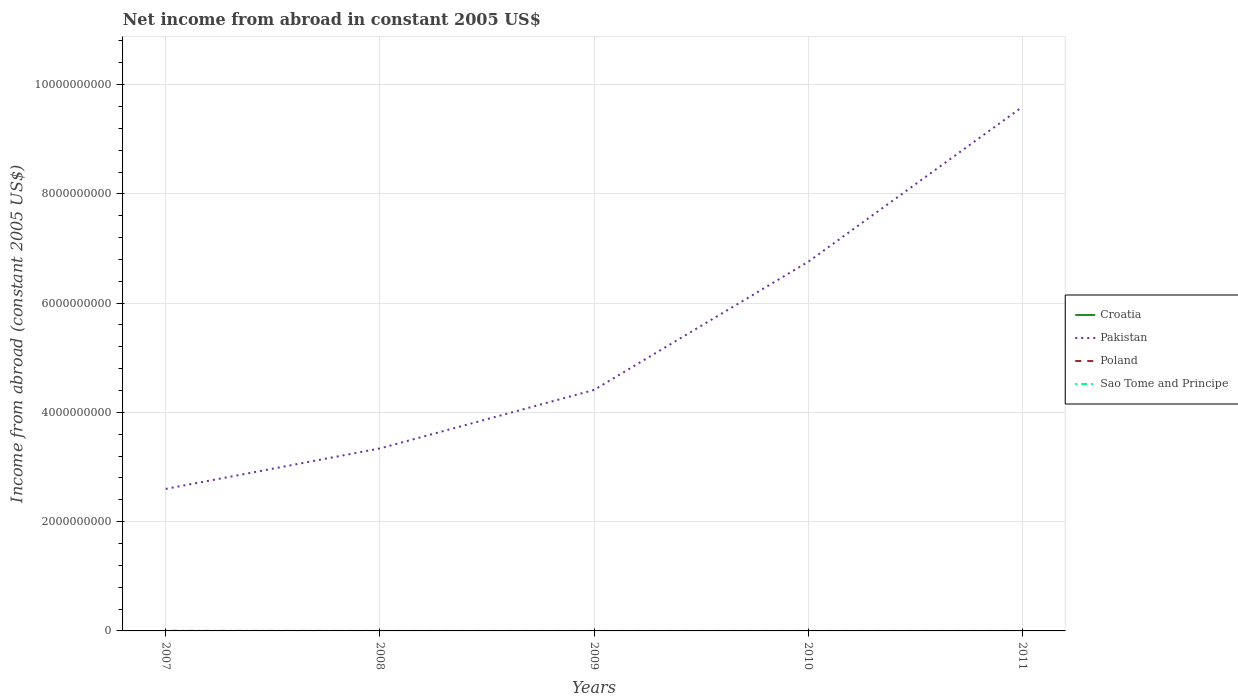How many different coloured lines are there?
Your answer should be very brief. 2. Does the line corresponding to Croatia intersect with the line corresponding to Pakistan?
Offer a very short reply. No. Is the number of lines equal to the number of legend labels?
Provide a short and direct response. No. Across all years, what is the maximum net income from abroad in Pakistan?
Your response must be concise. 2.60e+09. What is the total net income from abroad in Pakistan in the graph?
Offer a terse response. -4.16e+09. What is the difference between the highest and the second highest net income from abroad in Sao Tome and Principe?
Your response must be concise. 4.47e+06. How many lines are there?
Provide a succinct answer. 2. Are the values on the major ticks of Y-axis written in scientific E-notation?
Offer a terse response. No. Does the graph contain any zero values?
Offer a very short reply. Yes. Does the graph contain grids?
Ensure brevity in your answer.  Yes. Where does the legend appear in the graph?
Offer a very short reply. Center right. How many legend labels are there?
Provide a succinct answer. 4. What is the title of the graph?
Keep it short and to the point. Net income from abroad in constant 2005 US$. What is the label or title of the X-axis?
Your answer should be very brief. Years. What is the label or title of the Y-axis?
Your answer should be very brief. Income from abroad (constant 2005 US$). What is the Income from abroad (constant 2005 US$) in Pakistan in 2007?
Make the answer very short. 2.60e+09. What is the Income from abroad (constant 2005 US$) of Poland in 2007?
Provide a short and direct response. 0. What is the Income from abroad (constant 2005 US$) of Sao Tome and Principe in 2007?
Keep it short and to the point. 4.47e+06. What is the Income from abroad (constant 2005 US$) in Croatia in 2008?
Offer a very short reply. 0. What is the Income from abroad (constant 2005 US$) in Pakistan in 2008?
Your response must be concise. 3.34e+09. What is the Income from abroad (constant 2005 US$) in Poland in 2008?
Offer a very short reply. 0. What is the Income from abroad (constant 2005 US$) in Pakistan in 2009?
Your answer should be compact. 4.41e+09. What is the Income from abroad (constant 2005 US$) of Sao Tome and Principe in 2009?
Make the answer very short. 0. What is the Income from abroad (constant 2005 US$) in Croatia in 2010?
Give a very brief answer. 0. What is the Income from abroad (constant 2005 US$) of Pakistan in 2010?
Give a very brief answer. 6.76e+09. What is the Income from abroad (constant 2005 US$) of Poland in 2010?
Keep it short and to the point. 0. What is the Income from abroad (constant 2005 US$) in Pakistan in 2011?
Provide a succinct answer. 9.59e+09. What is the Income from abroad (constant 2005 US$) in Poland in 2011?
Your response must be concise. 0. Across all years, what is the maximum Income from abroad (constant 2005 US$) in Pakistan?
Provide a short and direct response. 9.59e+09. Across all years, what is the maximum Income from abroad (constant 2005 US$) in Sao Tome and Principe?
Provide a succinct answer. 4.47e+06. Across all years, what is the minimum Income from abroad (constant 2005 US$) in Pakistan?
Offer a terse response. 2.60e+09. Across all years, what is the minimum Income from abroad (constant 2005 US$) of Sao Tome and Principe?
Provide a short and direct response. 0. What is the total Income from abroad (constant 2005 US$) in Croatia in the graph?
Provide a short and direct response. 0. What is the total Income from abroad (constant 2005 US$) in Pakistan in the graph?
Ensure brevity in your answer.  2.67e+1. What is the total Income from abroad (constant 2005 US$) in Poland in the graph?
Your response must be concise. 0. What is the total Income from abroad (constant 2005 US$) of Sao Tome and Principe in the graph?
Your response must be concise. 4.47e+06. What is the difference between the Income from abroad (constant 2005 US$) in Pakistan in 2007 and that in 2008?
Offer a very short reply. -7.40e+08. What is the difference between the Income from abroad (constant 2005 US$) in Pakistan in 2007 and that in 2009?
Make the answer very short. -1.81e+09. What is the difference between the Income from abroad (constant 2005 US$) in Pakistan in 2007 and that in 2010?
Offer a very short reply. -4.16e+09. What is the difference between the Income from abroad (constant 2005 US$) of Pakistan in 2007 and that in 2011?
Your answer should be compact. -6.99e+09. What is the difference between the Income from abroad (constant 2005 US$) in Pakistan in 2008 and that in 2009?
Make the answer very short. -1.07e+09. What is the difference between the Income from abroad (constant 2005 US$) of Pakistan in 2008 and that in 2010?
Make the answer very short. -3.42e+09. What is the difference between the Income from abroad (constant 2005 US$) in Pakistan in 2008 and that in 2011?
Ensure brevity in your answer.  -6.25e+09. What is the difference between the Income from abroad (constant 2005 US$) in Pakistan in 2009 and that in 2010?
Provide a succinct answer. -2.35e+09. What is the difference between the Income from abroad (constant 2005 US$) of Pakistan in 2009 and that in 2011?
Make the answer very short. -5.18e+09. What is the difference between the Income from abroad (constant 2005 US$) of Pakistan in 2010 and that in 2011?
Keep it short and to the point. -2.84e+09. What is the average Income from abroad (constant 2005 US$) in Croatia per year?
Ensure brevity in your answer.  0. What is the average Income from abroad (constant 2005 US$) of Pakistan per year?
Provide a short and direct response. 5.34e+09. What is the average Income from abroad (constant 2005 US$) in Poland per year?
Provide a short and direct response. 0. What is the average Income from abroad (constant 2005 US$) of Sao Tome and Principe per year?
Give a very brief answer. 8.95e+05. In the year 2007, what is the difference between the Income from abroad (constant 2005 US$) of Pakistan and Income from abroad (constant 2005 US$) of Sao Tome and Principe?
Your answer should be very brief. 2.60e+09. What is the ratio of the Income from abroad (constant 2005 US$) of Pakistan in 2007 to that in 2008?
Make the answer very short. 0.78. What is the ratio of the Income from abroad (constant 2005 US$) in Pakistan in 2007 to that in 2009?
Make the answer very short. 0.59. What is the ratio of the Income from abroad (constant 2005 US$) in Pakistan in 2007 to that in 2010?
Your response must be concise. 0.38. What is the ratio of the Income from abroad (constant 2005 US$) of Pakistan in 2007 to that in 2011?
Your answer should be very brief. 0.27. What is the ratio of the Income from abroad (constant 2005 US$) in Pakistan in 2008 to that in 2009?
Provide a short and direct response. 0.76. What is the ratio of the Income from abroad (constant 2005 US$) in Pakistan in 2008 to that in 2010?
Your answer should be very brief. 0.49. What is the ratio of the Income from abroad (constant 2005 US$) of Pakistan in 2008 to that in 2011?
Provide a succinct answer. 0.35. What is the ratio of the Income from abroad (constant 2005 US$) in Pakistan in 2009 to that in 2010?
Offer a very short reply. 0.65. What is the ratio of the Income from abroad (constant 2005 US$) in Pakistan in 2009 to that in 2011?
Your response must be concise. 0.46. What is the ratio of the Income from abroad (constant 2005 US$) of Pakistan in 2010 to that in 2011?
Make the answer very short. 0.7. What is the difference between the highest and the second highest Income from abroad (constant 2005 US$) in Pakistan?
Give a very brief answer. 2.84e+09. What is the difference between the highest and the lowest Income from abroad (constant 2005 US$) of Pakistan?
Your answer should be compact. 6.99e+09. What is the difference between the highest and the lowest Income from abroad (constant 2005 US$) of Sao Tome and Principe?
Give a very brief answer. 4.47e+06. 